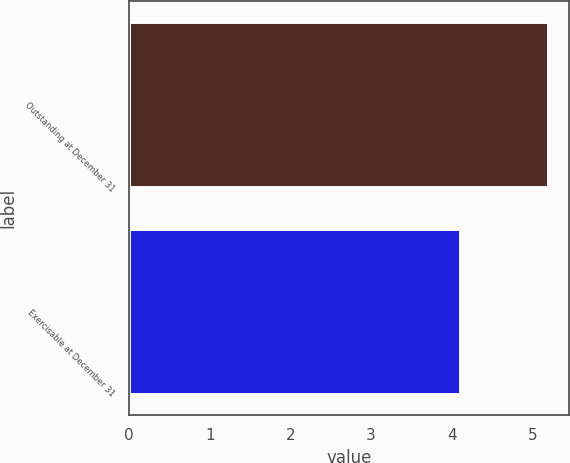Convert chart. <chart><loc_0><loc_0><loc_500><loc_500><bar_chart><fcel>Outstanding at December 31<fcel>Exercisable at December 31<nl><fcel>5.2<fcel>4.1<nl></chart> 